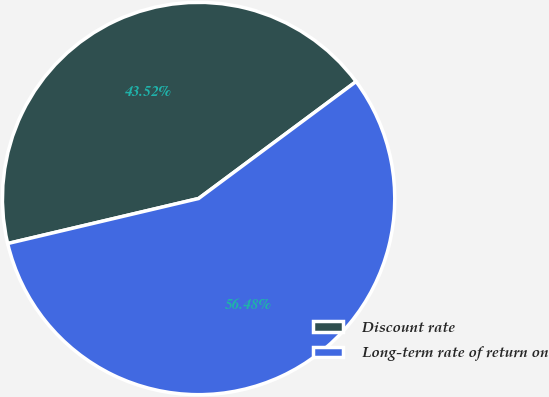Convert chart to OTSL. <chart><loc_0><loc_0><loc_500><loc_500><pie_chart><fcel>Discount rate<fcel>Long-term rate of return on<nl><fcel>43.52%<fcel>56.48%<nl></chart> 